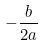<formula> <loc_0><loc_0><loc_500><loc_500>- \frac { b } { 2 a }</formula> 